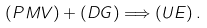Convert formula to latex. <formula><loc_0><loc_0><loc_500><loc_500>\left ( P M V \right ) + \left ( D G \right ) \Longrightarrow \left ( U E \right ) .</formula> 